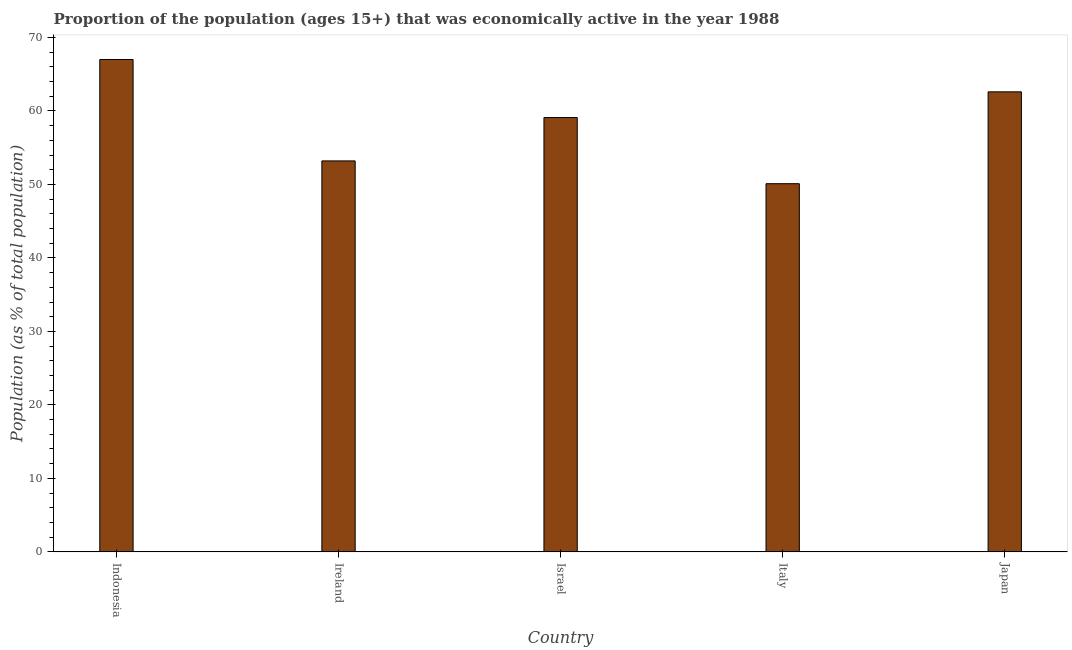What is the title of the graph?
Your answer should be very brief. Proportion of the population (ages 15+) that was economically active in the year 1988. What is the label or title of the Y-axis?
Your answer should be compact. Population (as % of total population). What is the percentage of economically active population in Italy?
Give a very brief answer. 50.1. Across all countries, what is the maximum percentage of economically active population?
Provide a short and direct response. 67. Across all countries, what is the minimum percentage of economically active population?
Your response must be concise. 50.1. In which country was the percentage of economically active population maximum?
Ensure brevity in your answer.  Indonesia. In which country was the percentage of economically active population minimum?
Your answer should be very brief. Italy. What is the sum of the percentage of economically active population?
Provide a succinct answer. 292. What is the average percentage of economically active population per country?
Ensure brevity in your answer.  58.4. What is the median percentage of economically active population?
Offer a very short reply. 59.1. What is the ratio of the percentage of economically active population in Indonesia to that in Italy?
Provide a succinct answer. 1.34. What is the difference between the highest and the lowest percentage of economically active population?
Keep it short and to the point. 16.9. How many bars are there?
Ensure brevity in your answer.  5. Are all the bars in the graph horizontal?
Offer a terse response. No. How many countries are there in the graph?
Provide a succinct answer. 5. Are the values on the major ticks of Y-axis written in scientific E-notation?
Ensure brevity in your answer.  No. What is the Population (as % of total population) of Ireland?
Give a very brief answer. 53.2. What is the Population (as % of total population) in Israel?
Offer a terse response. 59.1. What is the Population (as % of total population) of Italy?
Keep it short and to the point. 50.1. What is the Population (as % of total population) in Japan?
Your answer should be very brief. 62.6. What is the difference between the Population (as % of total population) in Indonesia and Israel?
Your response must be concise. 7.9. What is the difference between the Population (as % of total population) in Indonesia and Japan?
Keep it short and to the point. 4.4. What is the difference between the Population (as % of total population) in Ireland and Japan?
Your answer should be compact. -9.4. What is the difference between the Population (as % of total population) in Israel and Japan?
Provide a short and direct response. -3.5. What is the ratio of the Population (as % of total population) in Indonesia to that in Ireland?
Provide a short and direct response. 1.26. What is the ratio of the Population (as % of total population) in Indonesia to that in Israel?
Provide a succinct answer. 1.13. What is the ratio of the Population (as % of total population) in Indonesia to that in Italy?
Give a very brief answer. 1.34. What is the ratio of the Population (as % of total population) in Indonesia to that in Japan?
Your response must be concise. 1.07. What is the ratio of the Population (as % of total population) in Ireland to that in Israel?
Offer a terse response. 0.9. What is the ratio of the Population (as % of total population) in Ireland to that in Italy?
Ensure brevity in your answer.  1.06. What is the ratio of the Population (as % of total population) in Israel to that in Italy?
Provide a short and direct response. 1.18. What is the ratio of the Population (as % of total population) in Israel to that in Japan?
Make the answer very short. 0.94. 